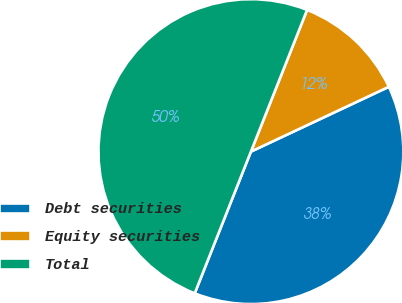Convert chart. <chart><loc_0><loc_0><loc_500><loc_500><pie_chart><fcel>Debt securities<fcel>Equity securities<fcel>Total<nl><fcel>38.0%<fcel>12.0%<fcel>50.0%<nl></chart> 